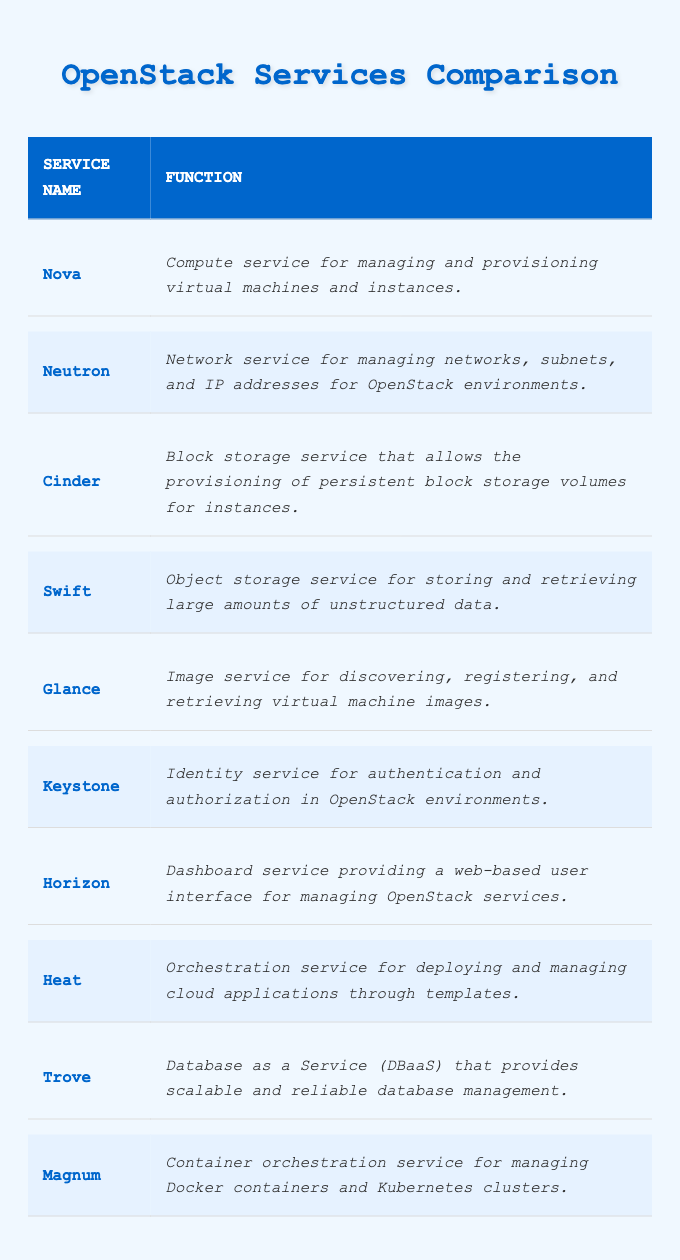What is the function of the Nova service? The Nova service is listed in the table, and its function is specified in the "Function" column as "Compute service for managing and provisioning virtual machines and instances."
Answer: Compute service for managing and provisioning virtual machines and instances Which OpenStack service provides identity management? Looking at the "Service Name" column, the service that focuses on identity management is Keystone, which is described in the function as "Identity service for authentication and authorization in OpenStack environments."
Answer: Keystone Is Cinder an object storage service? The table shows that Cinder is described as a "Block storage service that allows the provisioning of persistent block storage volumes for instances," which does not categorize it as an object storage service.
Answer: No How many services are focused on storage? By reviewing the services, Cinder (Block storage) and Swift (Object storage) both focus on storage. This results in a total of two services.
Answer: 2 Which service is used for managing Docker containers? From the "Service Name" column, Magnum is listed as the service for managing Docker containers and is described as "Container orchestration service for managing Docker containers and Kubernetes clusters."
Answer: Magnum What service is designed for web-based management? The table indicates that Horizon serves this purpose, as it is noted as the "Dashboard service providing a web-based user interface for managing OpenStack services."
Answer: Horizon Do any services have similar functions? Comparing the functions, while most services have distinct purposes, both Nova and Heat are related to managing resources in some capacity. Nova manages compute instances, and Heat orchestrates cloud applications, potentially utilizing compute resources.
Answer: Yes Which service involves orchestration and what does it do? The table details that the Heat service is the orchestration service and its function is "for deploying and managing cloud applications through templates," indicating its role in orchestrating resources and services.
Answer: Heat What is the combined focus of database and storage services in OpenStack? Cinder focuses on block storage, Trove on database management, and Swift on object storage. Combining these, OpenStack supports various storage types through Cinder, Swift, and database management through Trove. This sums up to three distinct service functions but includes both storage and database management.
Answer: 3 services with a focus on storage and database management Which service would you use to retrieve virtual machine images? The Glance service is identified in the table as the one for discovering, registering, and retrieving virtual machine images, thus, it is the correct service for this function.
Answer: Glance 